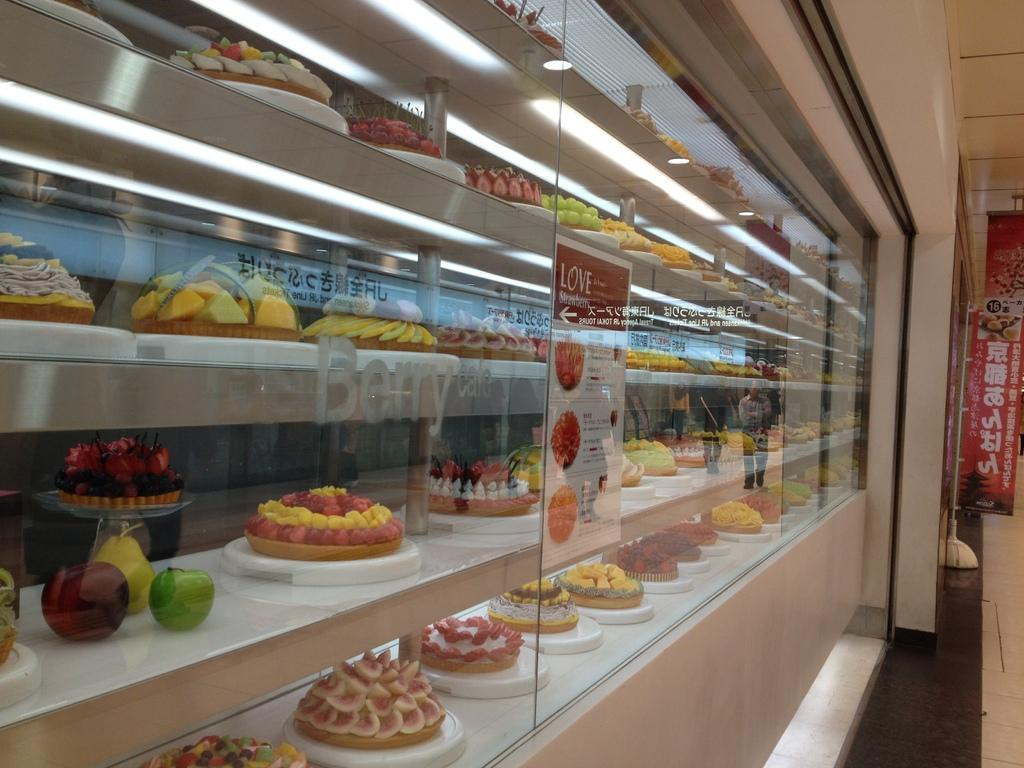<image>
Relay a brief, clear account of the picture shown. On the front of a glass case containing various desserts is a sign that reads "love strawberry." 